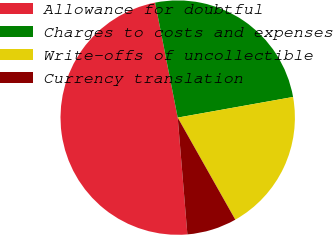Convert chart to OTSL. <chart><loc_0><loc_0><loc_500><loc_500><pie_chart><fcel>Allowance for doubtful<fcel>Charges to costs and expenses<fcel>Write-offs of uncollectible<fcel>Currency translation<nl><fcel>48.23%<fcel>25.27%<fcel>19.64%<fcel>6.86%<nl></chart> 